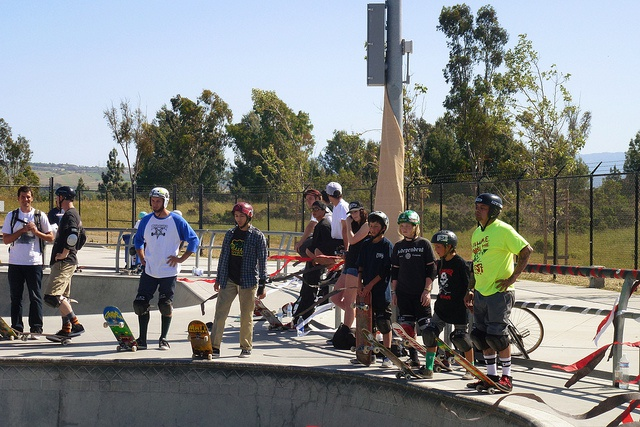Describe the objects in this image and their specific colors. I can see people in lightblue, black, olive, and maroon tones, people in lightblue, black, darkgray, and gray tones, people in lightblue, black, and gray tones, people in lightblue, black, maroon, and gray tones, and people in lightblue, black, gray, and maroon tones in this image. 